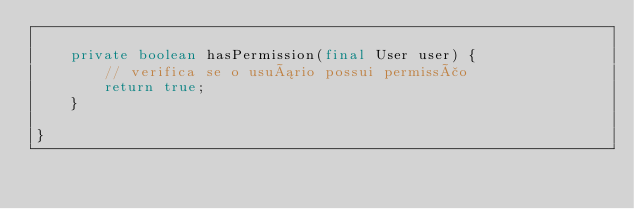Convert code to text. <code><loc_0><loc_0><loc_500><loc_500><_Java_>
    private boolean hasPermission(final User user) {
        // verifica se o usuário possui permissão
        return true;
    }

}</code> 